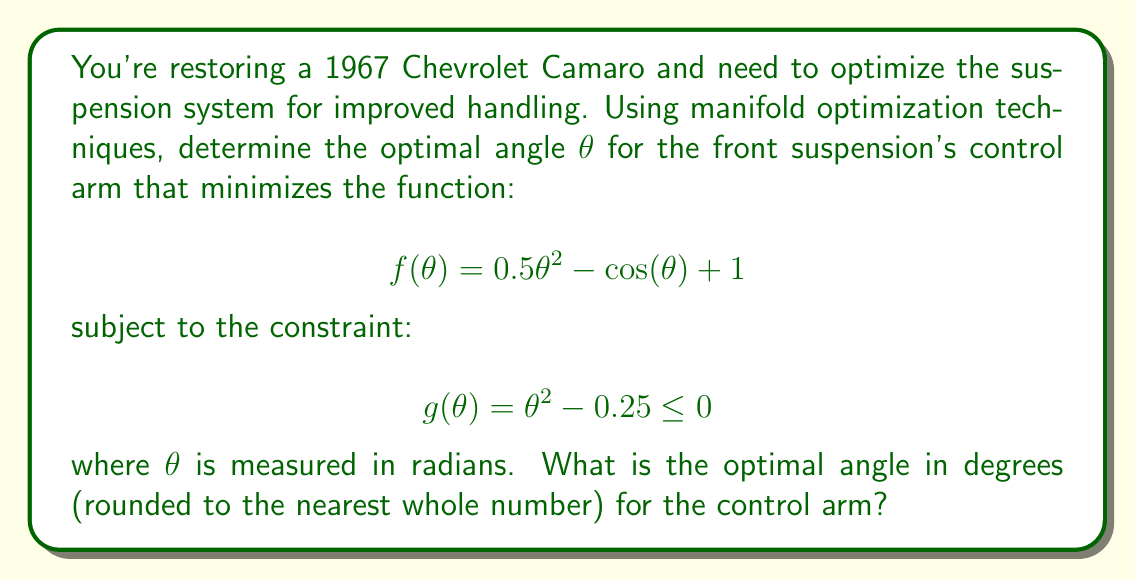Give your solution to this math problem. To solve this problem, we'll use the method of Lagrange multipliers on the manifold defined by the constraint.

1) First, we form the Lagrangian function:
   $$L(\theta, \lambda) = f(\theta) + \lambda g(\theta)$$
   $$L(\theta, \lambda) = 0.5\theta^2 - \cos(\theta) + 1 + \lambda(\theta^2 - 0.25)$$

2) We then find the critical points by setting the partial derivatives to zero:
   $$\frac{\partial L}{\partial \theta} = \theta + \sin(\theta) + 2\lambda\theta = 0$$
   $$\frac{\partial L}{\partial \lambda} = \theta^2 - 0.25 = 0$$

3) From the second equation, we get:
   $$\theta = \pm 0.5$$

4) Substituting this into the first equation:
   $$0.5 + \sin(0.5) + \lambda = 0$$
   $$\lambda = -0.5 - \sin(0.5) \approx -0.9794$$

5) We need to check both positive and negative values of θ:
   For θ = 0.5:
   $$f(0.5) = 0.5(0.5)^2 - \cos(0.5) + 1 \approx 1.4621$$
   
   For θ = -0.5:
   $$f(-0.5) = 0.5(-0.5)^2 - \cos(-0.5) + 1 \approx 1.4621$$

6) Both values give the same result, so either is a valid solution. We'll choose the positive value.

7) Convert radians to degrees:
   $$0.5 \text{ radians} \times \frac{180°}{\pi} \approx 28.6479°$$

8) Rounding to the nearest whole number: 29°
Answer: The optimal angle for the control arm is 29°. 